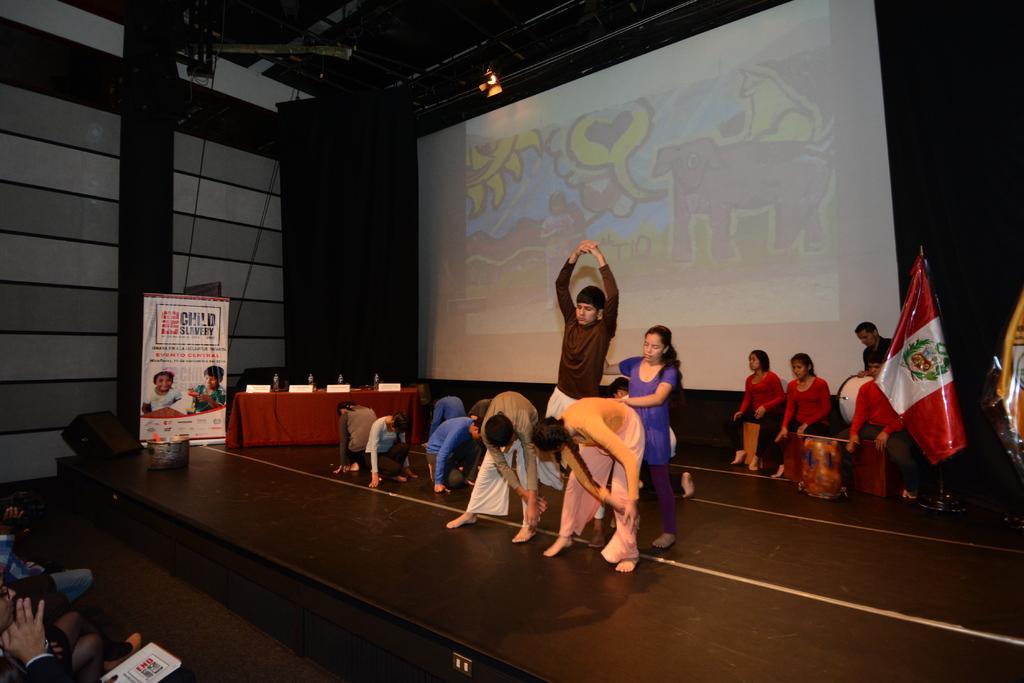How would you summarize this image in a sentence or two? In the center of the image we can see one stage. On the stage, we can see a few people are performing. In the bottom left side of the image, we can see a few people are sitting and we can see the corner person holding some object. In the background there is a screen, wall, roof, light, tablecloth, few people are sitting and holding some objects and a few other objects. 